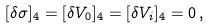<formula> <loc_0><loc_0><loc_500><loc_500>[ \delta \sigma ] _ { 4 } = [ \delta V _ { 0 } ] _ { 4 } = [ \delta V _ { i } ] _ { 4 } = 0 \, ,</formula> 